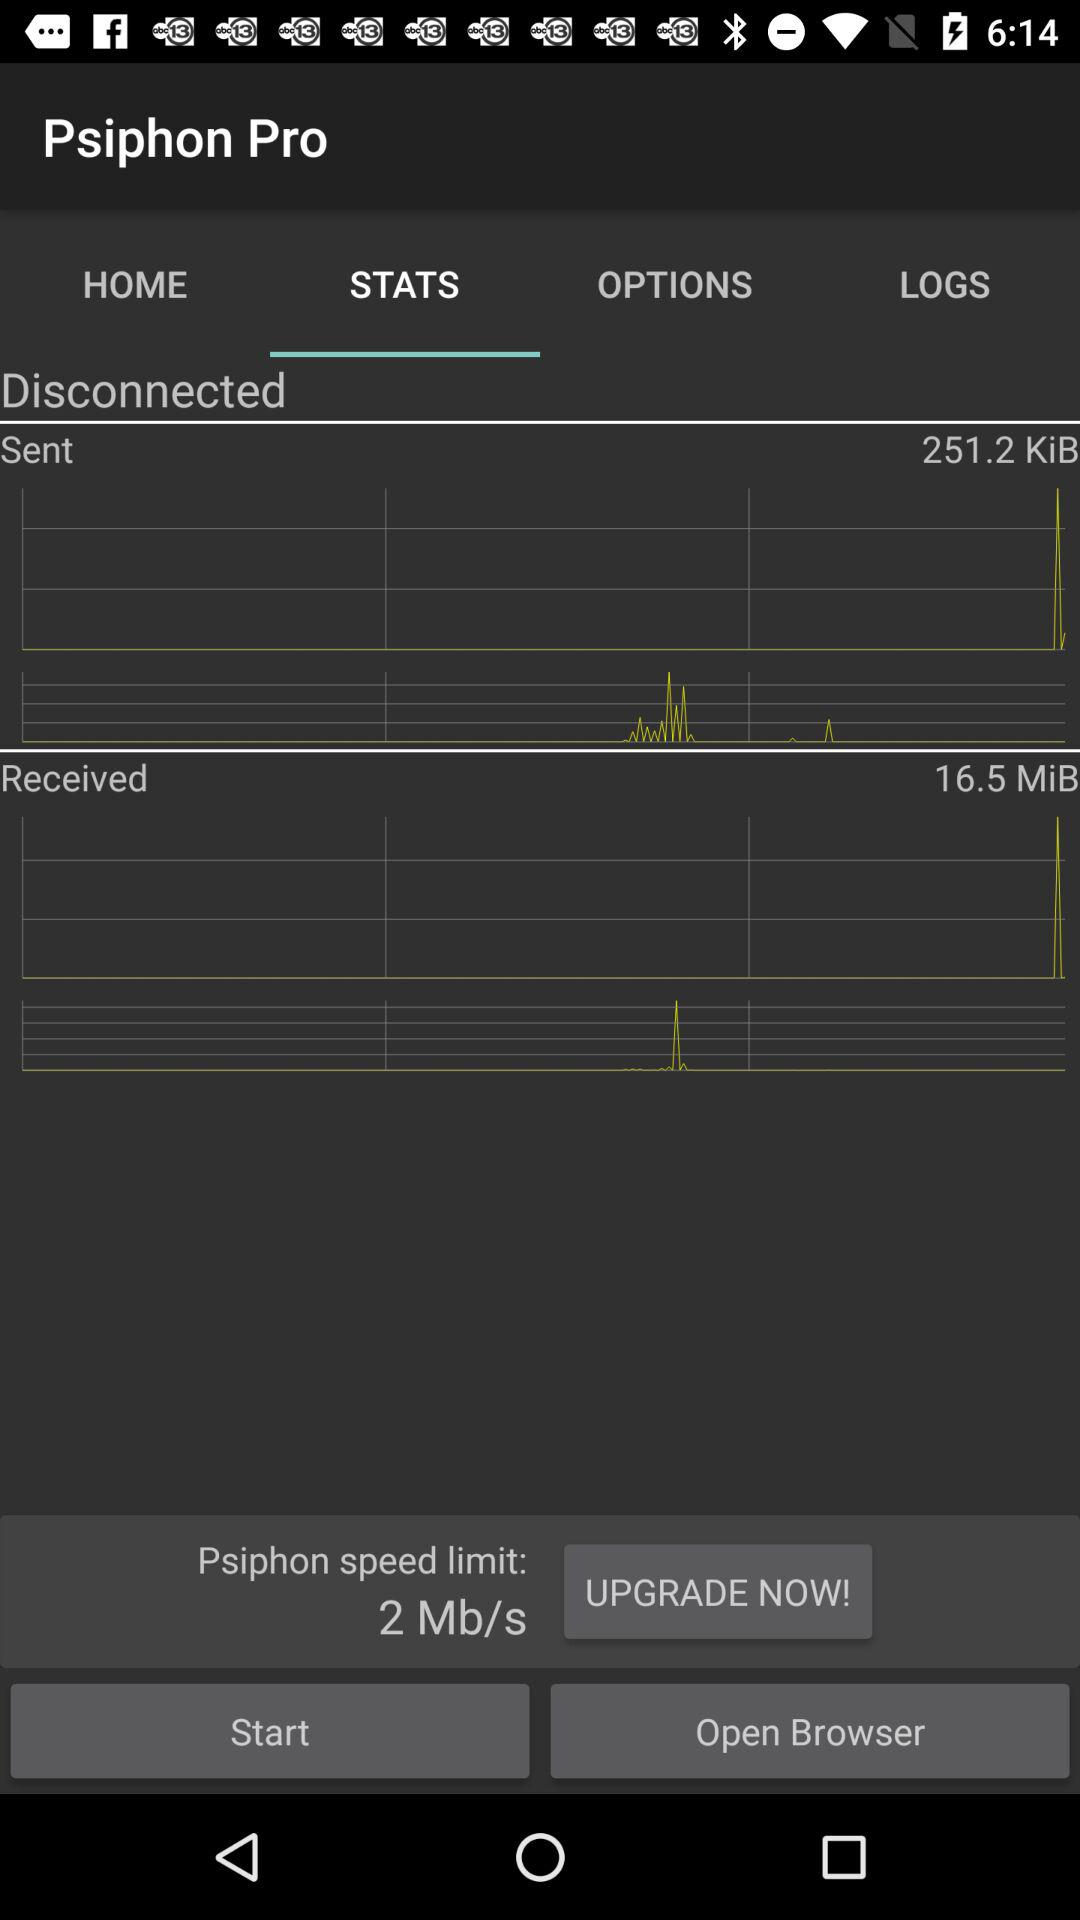How much data has been received in MiB? The data received in MiB is 16.5. 